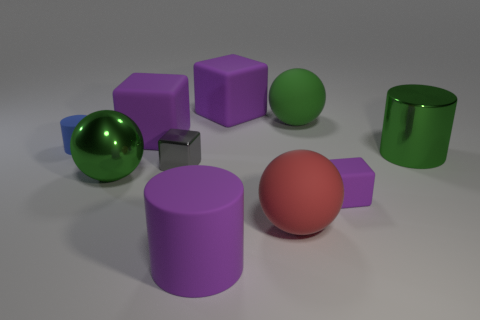Subtract all purple matte cylinders. How many cylinders are left? 2 Subtract all red cylinders. How many green spheres are left? 2 Subtract all gray blocks. How many blocks are left? 3 Subtract all cylinders. How many objects are left? 7 Subtract 1 blocks. How many blocks are left? 3 Subtract all yellow cylinders. Subtract all yellow spheres. How many cylinders are left? 3 Add 1 large green shiny cylinders. How many large green shiny cylinders are left? 2 Add 9 big purple rubber cylinders. How many big purple rubber cylinders exist? 10 Subtract 0 red blocks. How many objects are left? 10 Subtract all large matte cylinders. Subtract all big purple rubber cylinders. How many objects are left? 8 